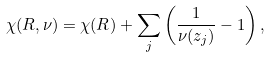<formula> <loc_0><loc_0><loc_500><loc_500>\chi ( R , \nu ) = \chi ( R ) + \sum _ { j } \left ( \frac { 1 } { \nu ( z _ { j } ) } - 1 \right ) ,</formula> 